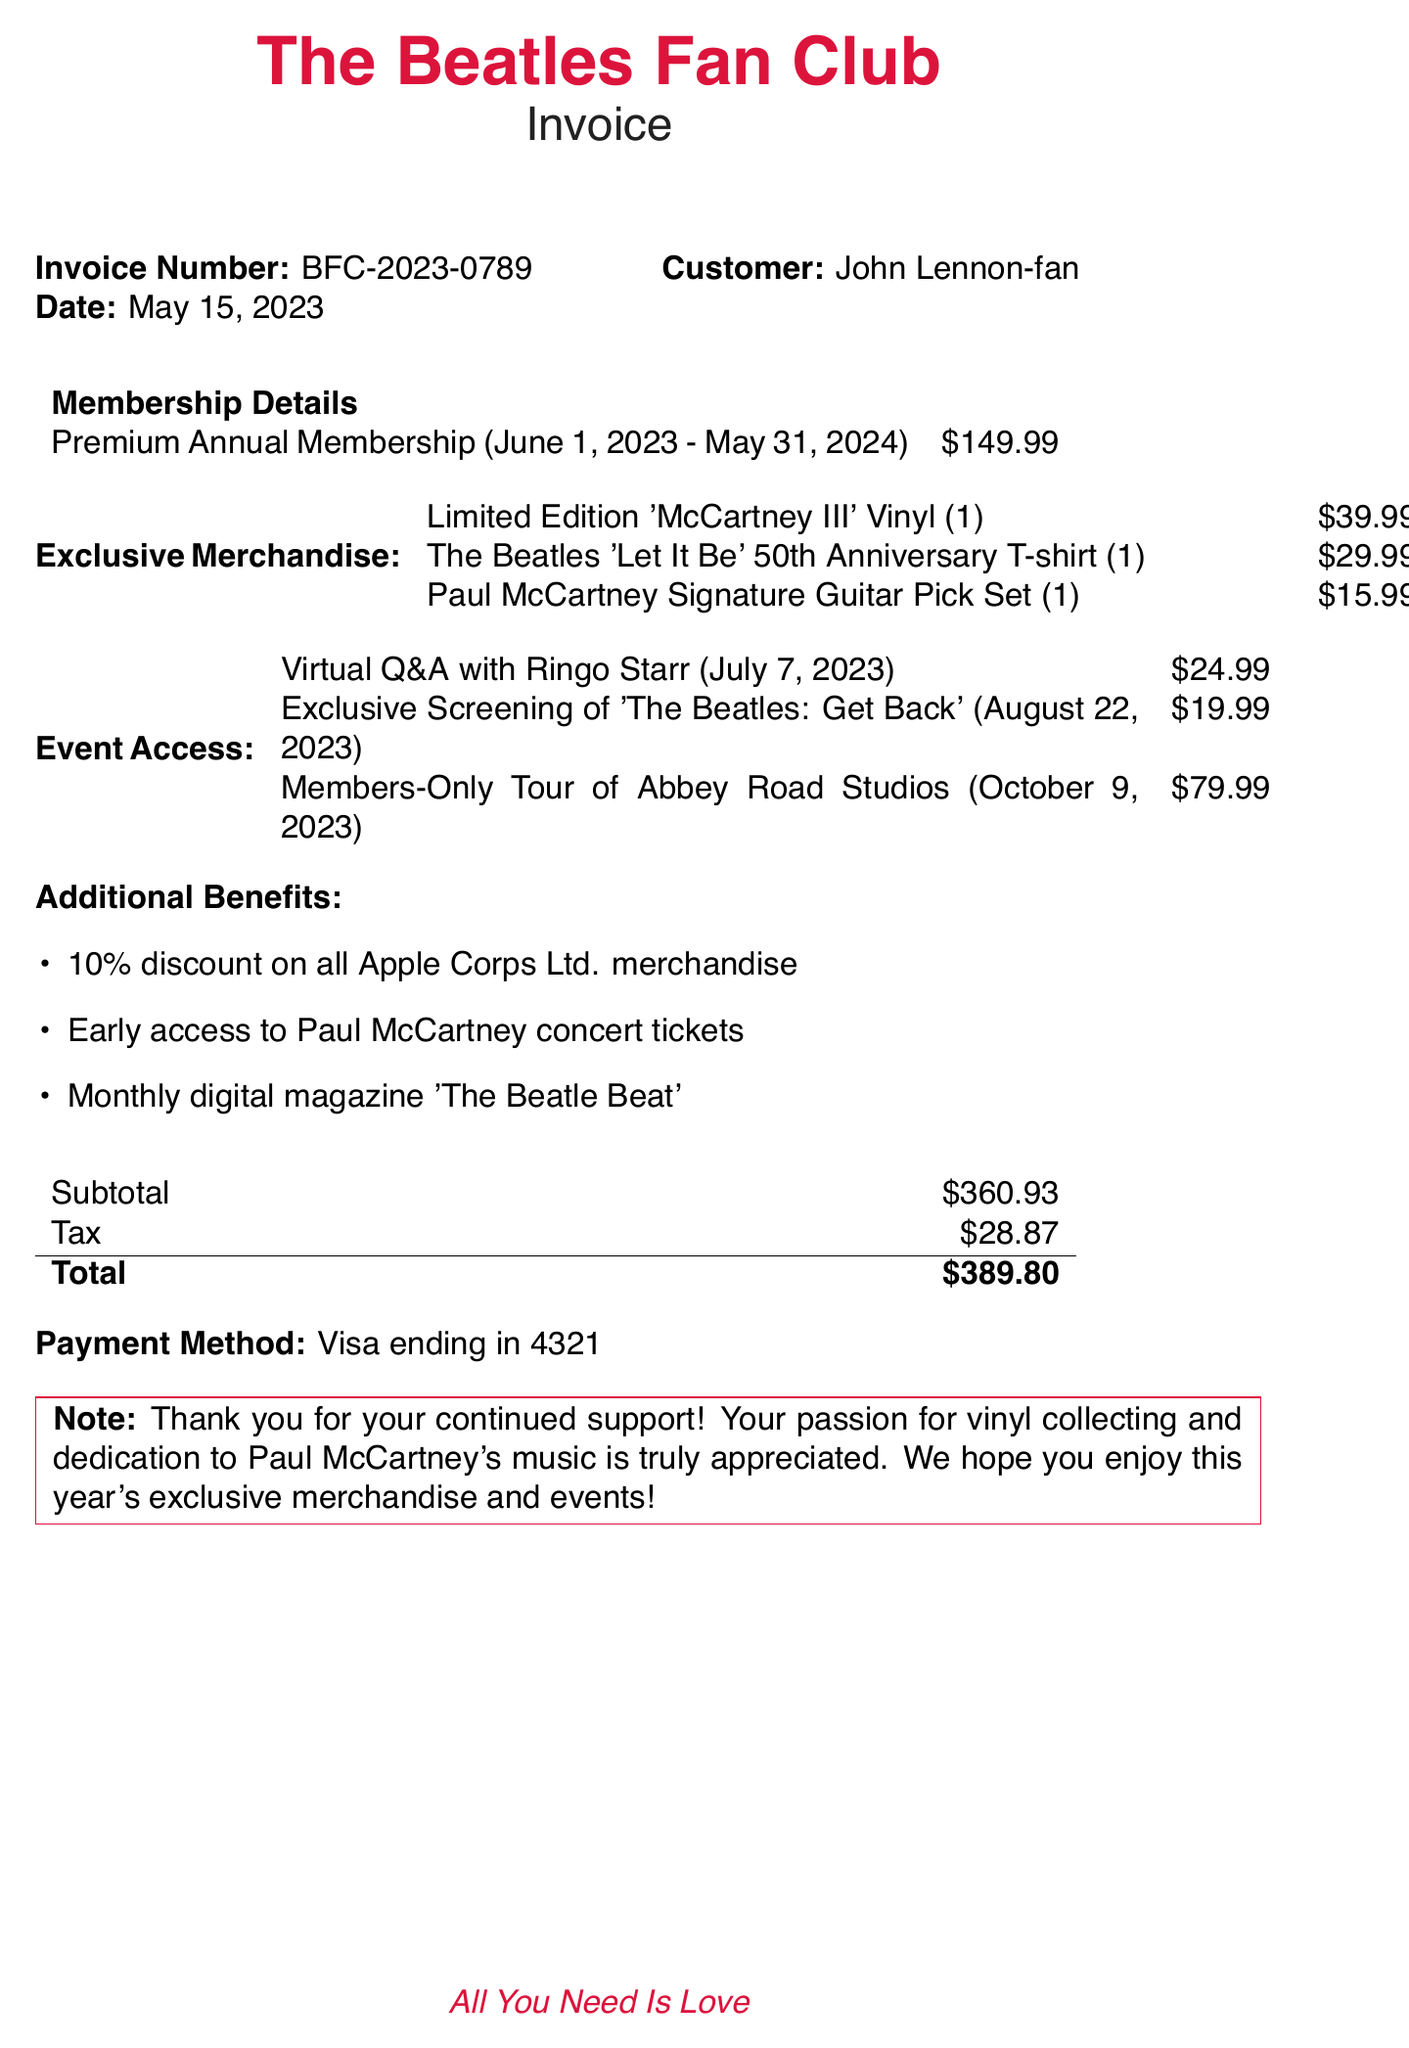What is the invoice number? The invoice number is clearly stated in the document, which is useful for reference.
Answer: BFC-2023-0789 What is the price of the Premium Annual Membership? The price for the membership is outlined alongside its details.
Answer: $149.99 On what date does the membership period begin? The start date of the membership period is specified in the membership details.
Answer: June 1, 2023 What is the total amount due? The total amount is calculated at the end of the invoice and is an important figure for payment.
Answer: $389.80 How many events does the member have access to? By counting the events listed, we can determine the number of events available to the member.
Answer: 3 What merchandise is included in the invoice? The exclusive merchandise is listed in detail in the invoice.
Answer: Limited Edition 'McCartney III' Vinyl, The Beatles 'Let It Be' 50th Anniversary T-shirt, Paul McCartney Signature Guitar Pick Set What is one of the additional benefits mentioned? Additional benefits are listed, any of which can be pointed out as a specific perk of membership.
Answer: 10% discount on all Apple Corps Ltd. merchandise When is the Virtual Q&A event scheduled? The date for the Virtual Q&A event is explicitly mentioned in the event access section.
Answer: July 7, 2023 